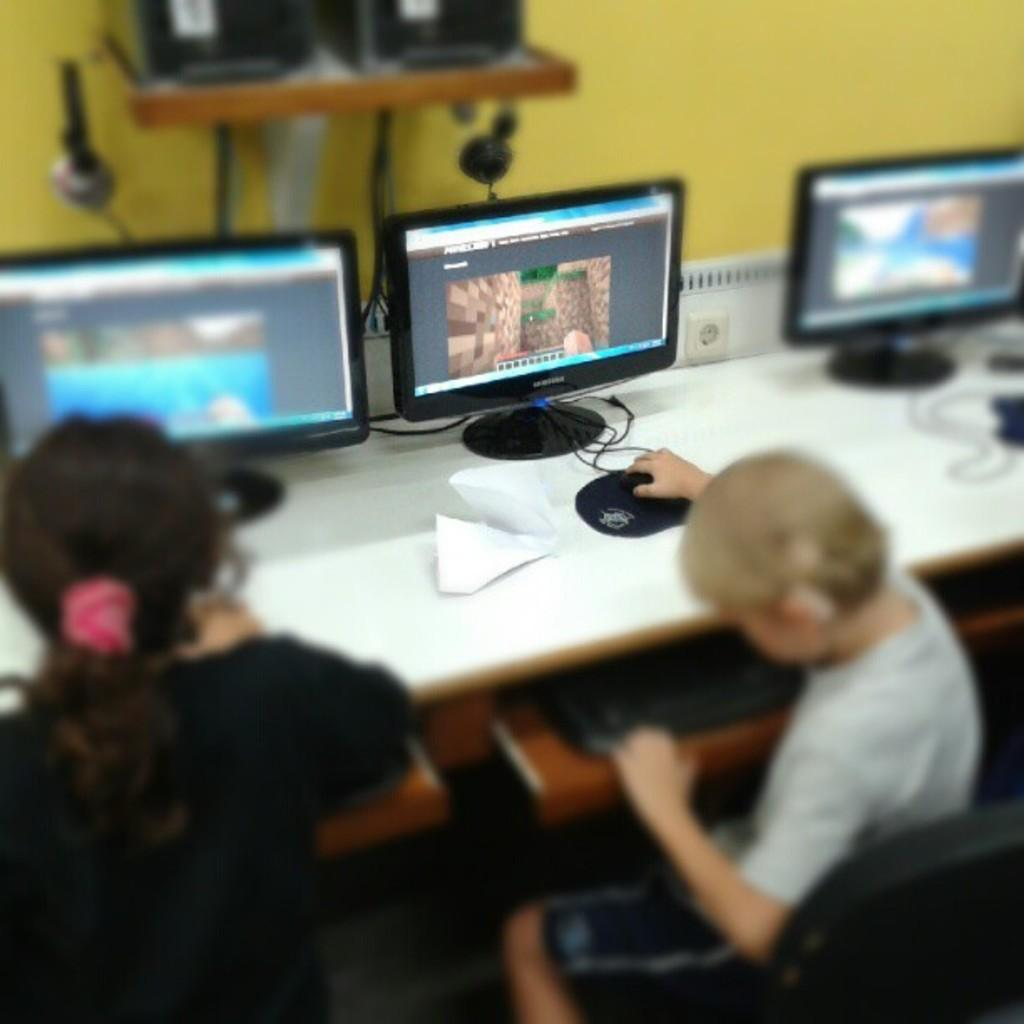How many children are in the image? There are two children in the image. What are the children doing in the image? The children are sitting on chairs. What is on the table in the image? There are monitors, paper, a mouse, and keyboards on the table. What is the color of the background in the image? The background of the image is yellow. How many buckets are visible in the image? There are no buckets present in the image. What type of men and women can be seen in the image? There are no men or women present in the image; it features two children. 